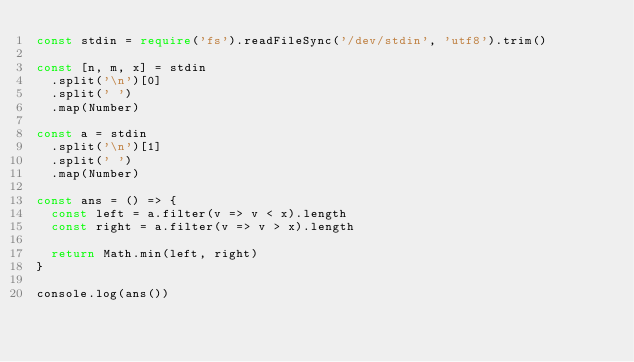Convert code to text. <code><loc_0><loc_0><loc_500><loc_500><_TypeScript_>const stdin = require('fs').readFileSync('/dev/stdin', 'utf8').trim()

const [n, m, x] = stdin
  .split('\n')[0]
  .split(' ')
  .map(Number)

const a = stdin
  .split('\n')[1]
  .split(' ')
  .map(Number)

const ans = () => {
  const left = a.filter(v => v < x).length
  const right = a.filter(v => v > x).length

  return Math.min(left, right)
}

console.log(ans())
</code> 